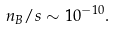<formula> <loc_0><loc_0><loc_500><loc_500>n _ { B } / s \sim 1 0 ^ { - 1 0 } .</formula> 